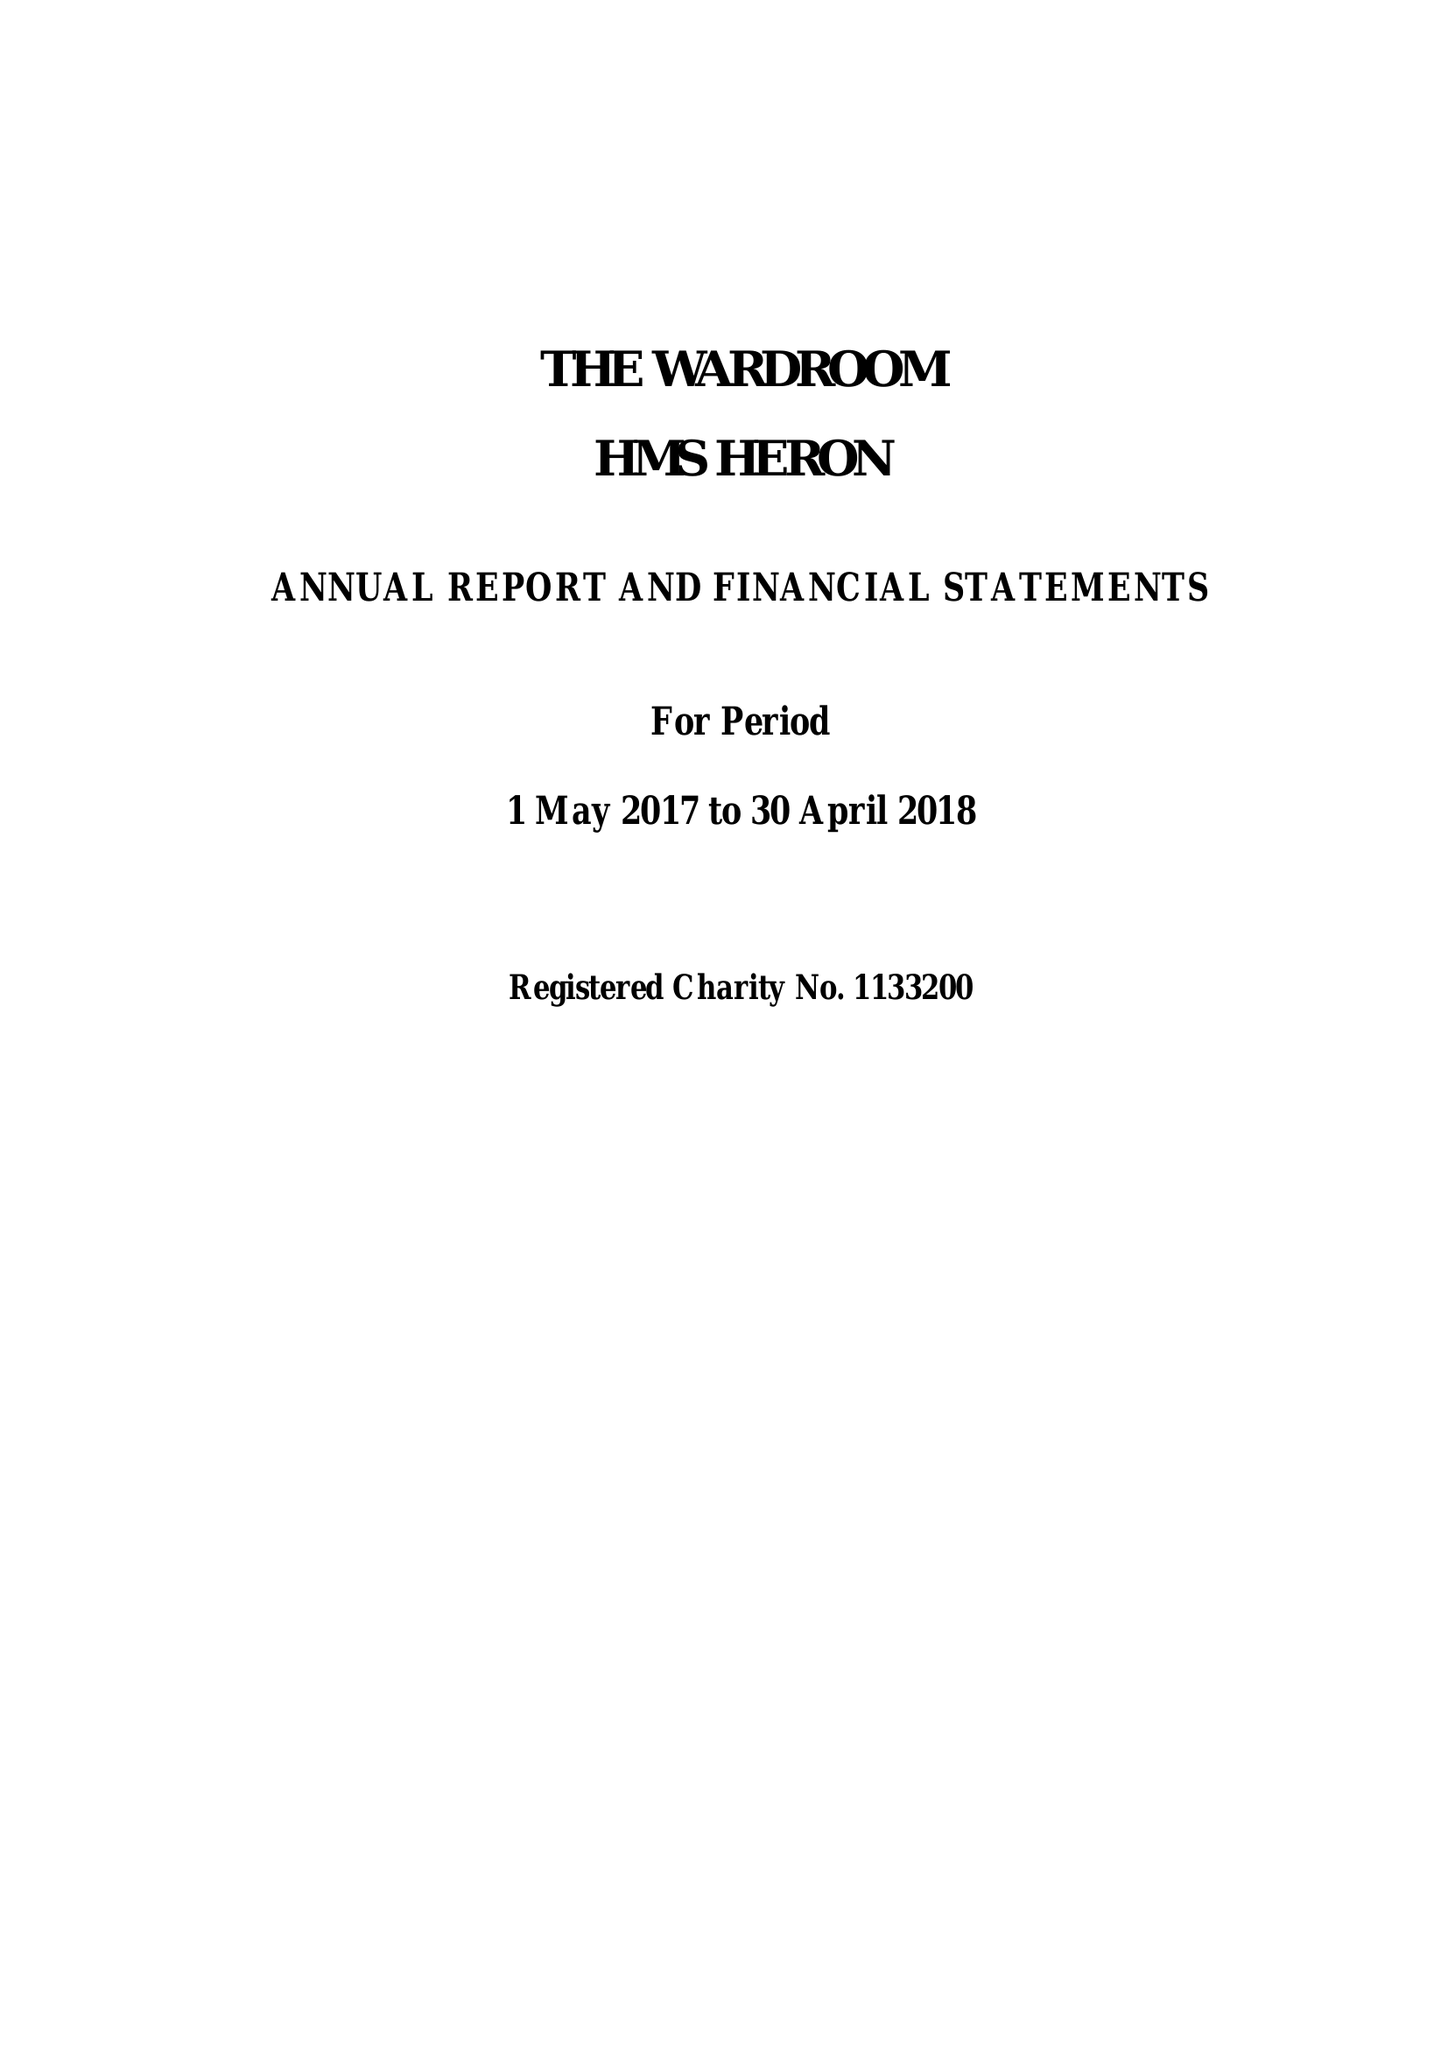What is the value for the address__post_town?
Answer the question using a single word or phrase. YEOVIL 